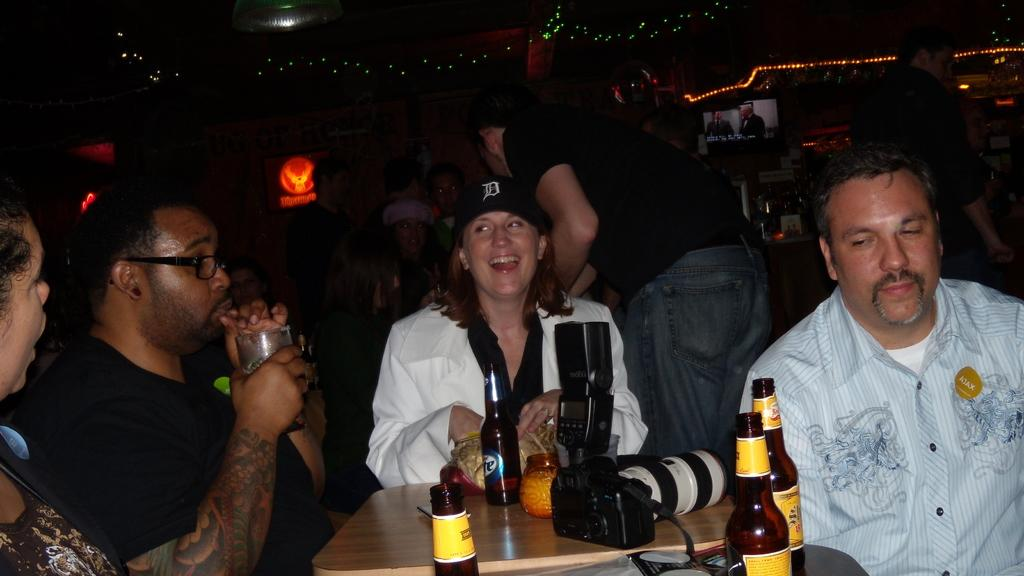What are the people in the image doing? There is a group of people sitting in chairs in the image. What is in front of the group of people? There is a table in front of the group of people. What can be seen on the table? The table has drink bottles on it and a camera. Can you describe the people in the background? There is another group of people in the background. What type of kettle is being used by the people in the image? There is no kettle present in the image. 